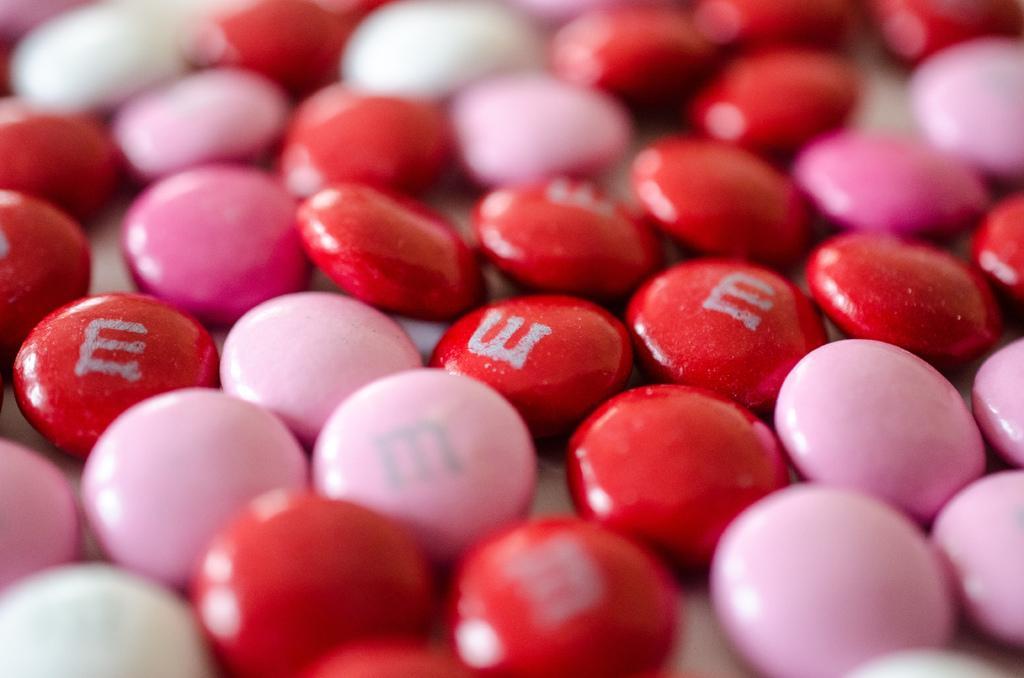Describe this image in one or two sentences. In this image I can see the germs which are in red, pink and white color. On the red color germs I can see the alphabet E is written. 